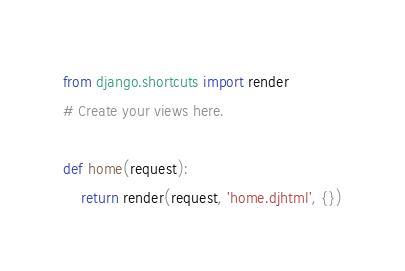Convert code to text. <code><loc_0><loc_0><loc_500><loc_500><_Python_>from django.shortcuts import render
# Create your views here.

def home(request):
    return render(request, 'home.djhtml', {})</code> 